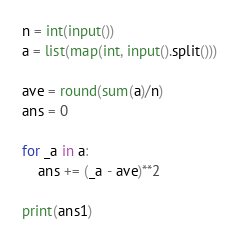Convert code to text. <code><loc_0><loc_0><loc_500><loc_500><_Python_>n = int(input())
a = list(map(int, input().split()))

ave = round(sum(a)/n)
ans = 0

for _a in a:
    ans += (_a - ave)**2

print(ans1)</code> 